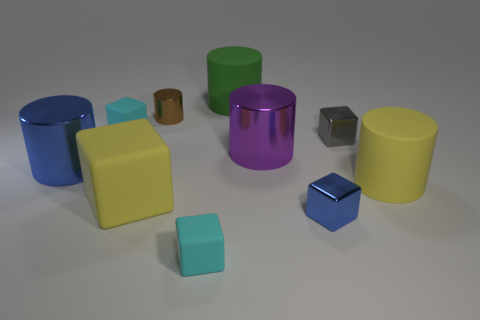Is there any other thing that is the same material as the green thing?
Keep it short and to the point. Yes. What shape is the large purple shiny thing?
Provide a succinct answer. Cylinder. Is the material of the tiny brown object the same as the blue cylinder in front of the brown cylinder?
Make the answer very short. Yes. What number of rubber objects are either green cylinders or large blocks?
Provide a succinct answer. 2. What is the size of the yellow object on the left side of the green rubber thing?
Keep it short and to the point. Large. The blue cube that is made of the same material as the brown object is what size?
Give a very brief answer. Small. How many big cylinders are the same color as the large matte block?
Provide a short and direct response. 1. Is there a big purple metal cylinder?
Give a very brief answer. Yes. Is the shape of the large blue thing the same as the large yellow rubber object on the left side of the yellow matte cylinder?
Your response must be concise. No. There is a rubber thing to the right of the blue metal block that is in front of the large cylinder right of the large purple metallic object; what color is it?
Make the answer very short. Yellow. 